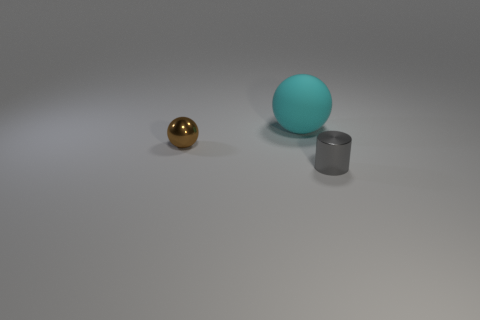Add 3 brown shiny spheres. How many objects exist? 6 Subtract all balls. How many objects are left? 1 Subtract all red spheres. Subtract all blue cylinders. How many spheres are left? 2 Subtract all big brown objects. Subtract all small brown metal objects. How many objects are left? 2 Add 1 gray metal cylinders. How many gray metal cylinders are left? 2 Add 2 gray matte balls. How many gray matte balls exist? 2 Subtract 0 gray blocks. How many objects are left? 3 